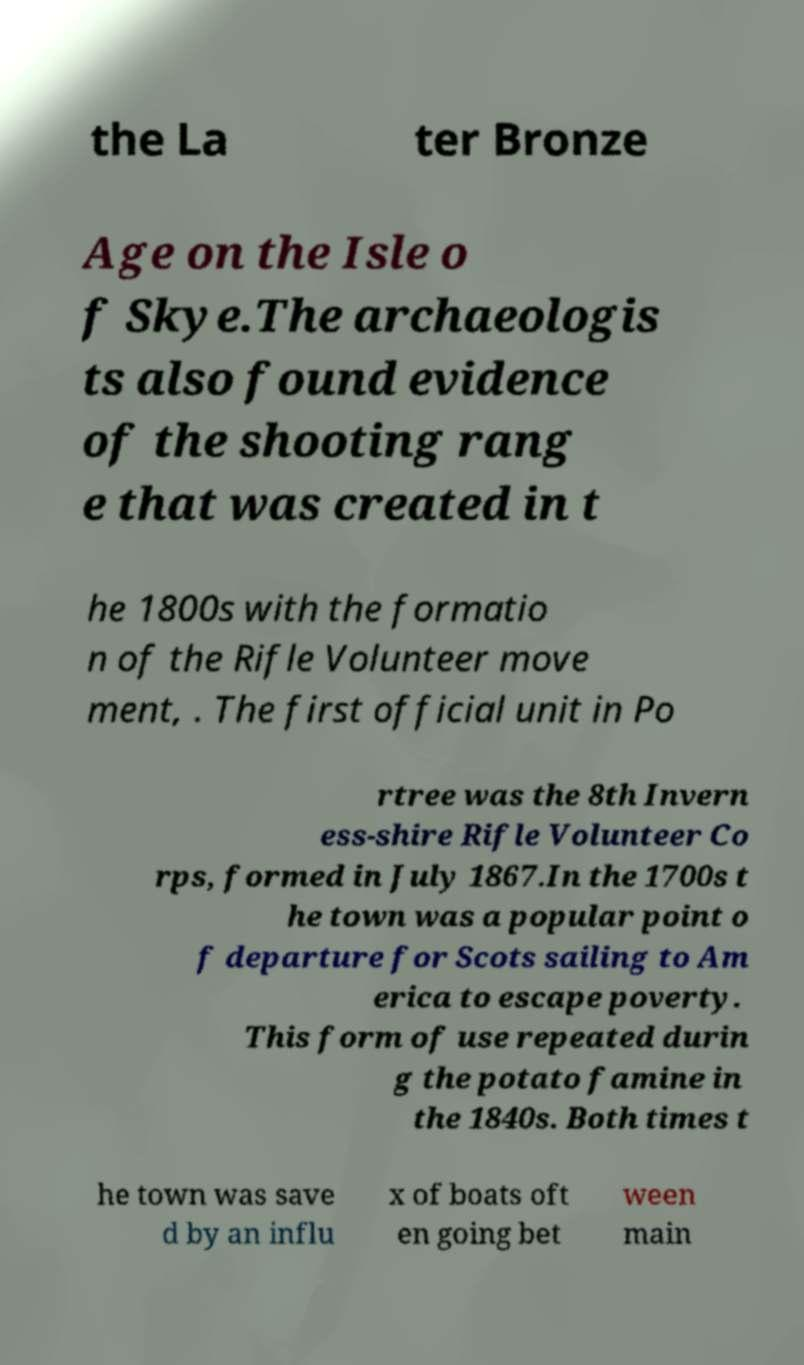What messages or text are displayed in this image? I need them in a readable, typed format. the La ter Bronze Age on the Isle o f Skye.The archaeologis ts also found evidence of the shooting rang e that was created in t he 1800s with the formatio n of the Rifle Volunteer move ment, . The first official unit in Po rtree was the 8th Invern ess-shire Rifle Volunteer Co rps, formed in July 1867.In the 1700s t he town was a popular point o f departure for Scots sailing to Am erica to escape poverty. This form of use repeated durin g the potato famine in the 1840s. Both times t he town was save d by an influ x of boats oft en going bet ween main 